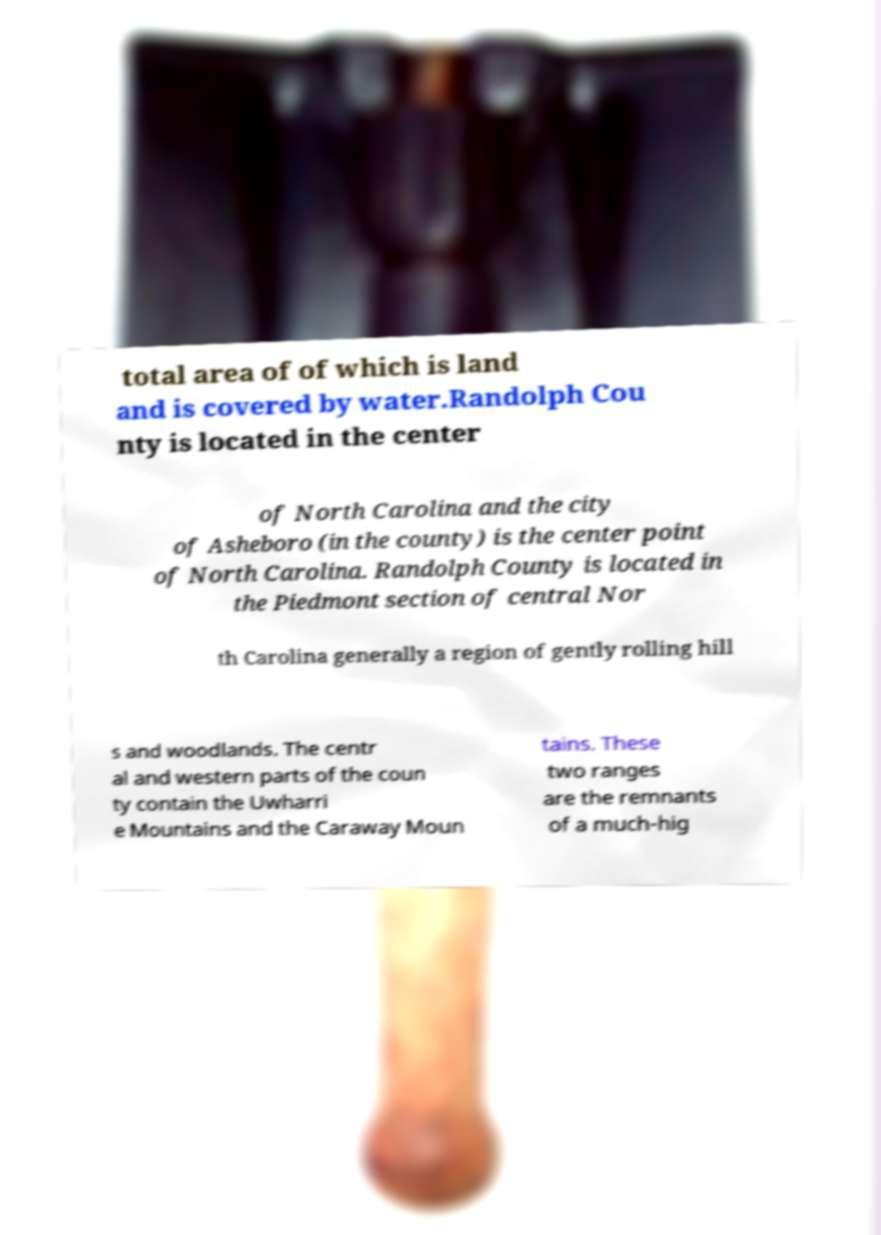For documentation purposes, I need the text within this image transcribed. Could you provide that? total area of of which is land and is covered by water.Randolph Cou nty is located in the center of North Carolina and the city of Asheboro (in the county) is the center point of North Carolina. Randolph County is located in the Piedmont section of central Nor th Carolina generally a region of gently rolling hill s and woodlands. The centr al and western parts of the coun ty contain the Uwharri e Mountains and the Caraway Moun tains. These two ranges are the remnants of a much-hig 